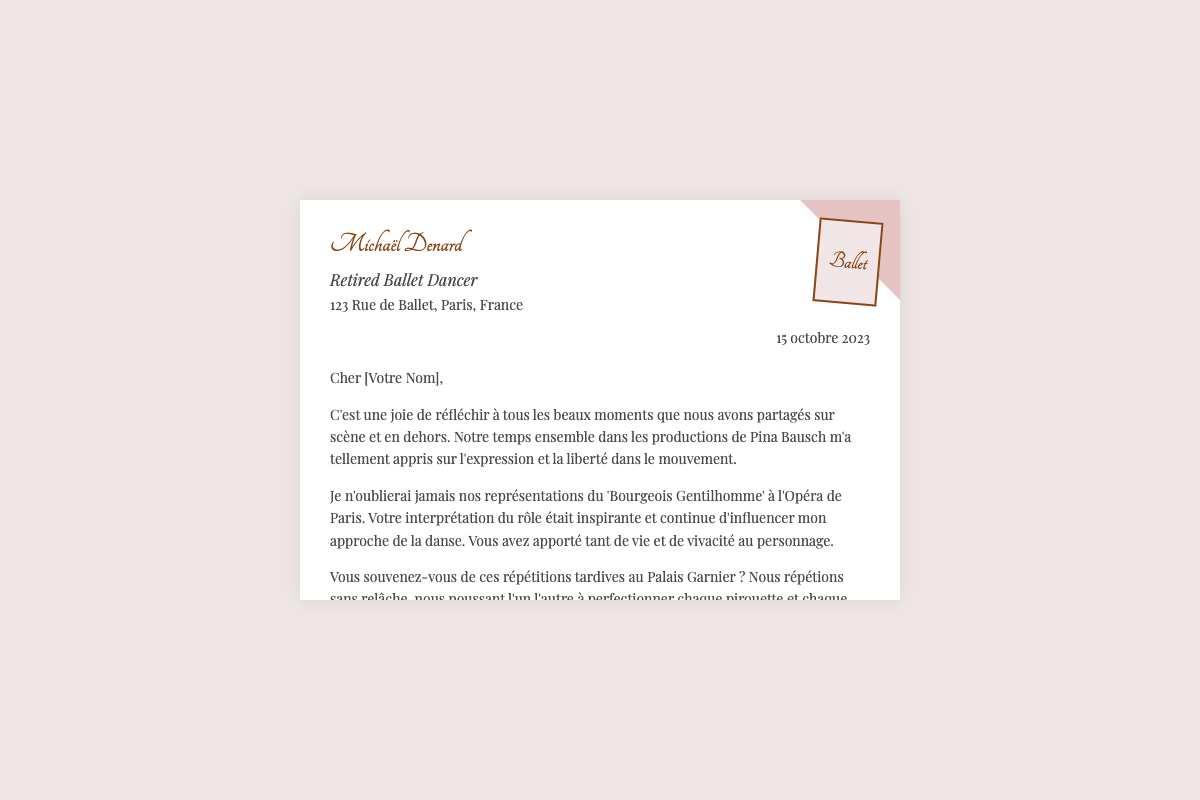What is the date on the card? The date on the card is present in the designated date section of the envelope.
Answer: 15 octobre 2023 Who is the sender of the card? The sender's name is highlighted at the top in a stylish font, representing the identity of the person sending the card.
Answer: Michaël Denard What performance is mentioned in the card? The card references a specific performance that holds meaning for both the sender and the recipient, showcasing their shared memories.
Answer: 'Bourgeois Gentilhomme' Which venue is referenced in the memories? The venue where they performed is mentioned in the context of their shared rehearsals.
Answer: Opéra de Paris What is the main emotion expressed in the card? The overall tone of the card indicates the emotion conveyed by the sender, reflecting their sentiments about past experiences.
Answer: Joie What type of card is this? The document is specifically designed as a card celebrating a personal occasion, categorized by its format and content.
Answer: Carte d'Anniversaire What term is used to describe the relationship between the sender and recipient? The tone and content imply a sense of closeness and fondness between the two dancers.
Answer: Amitiés In what context do they recall rehearsals? The card mentions the timing of their practices, underlining the dedication seen in their work.
Answer: Tardives 